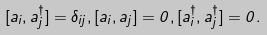<formula> <loc_0><loc_0><loc_500><loc_500>[ a _ { i } , a _ { j } ^ { \dagger } ] = \delta _ { i j } , [ a _ { i } , a _ { j } ] = 0 , [ a _ { i } ^ { \dagger } , a _ { j } ^ { \dagger } ] = 0 .</formula> 